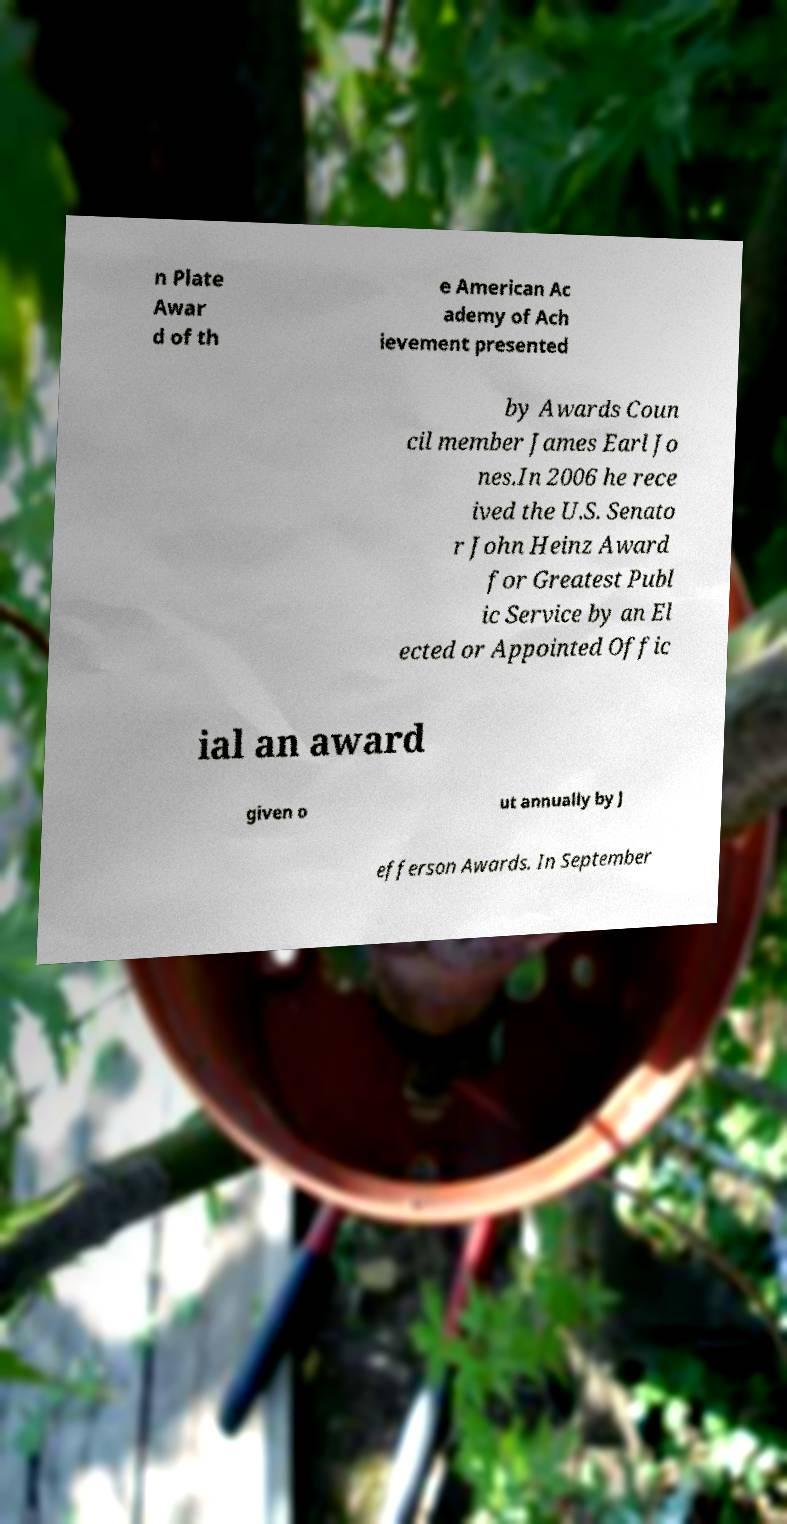What messages or text are displayed in this image? I need them in a readable, typed format. n Plate Awar d of th e American Ac ademy of Ach ievement presented by Awards Coun cil member James Earl Jo nes.In 2006 he rece ived the U.S. Senato r John Heinz Award for Greatest Publ ic Service by an El ected or Appointed Offic ial an award given o ut annually by J efferson Awards. In September 